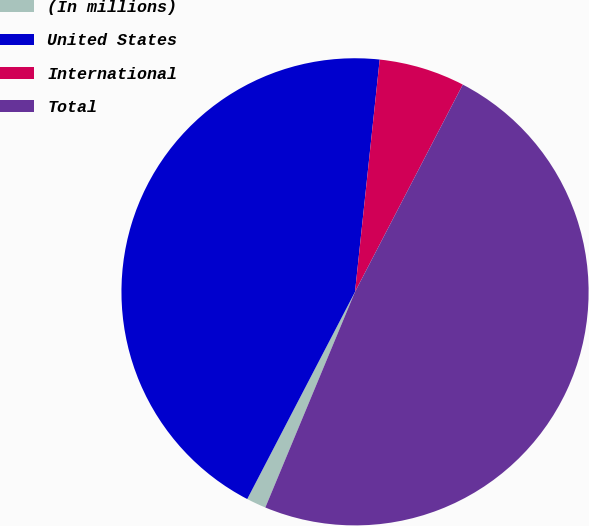Convert chart. <chart><loc_0><loc_0><loc_500><loc_500><pie_chart><fcel>(In millions)<fcel>United States<fcel>International<fcel>Total<nl><fcel>1.36%<fcel>44.05%<fcel>5.95%<fcel>48.64%<nl></chart> 